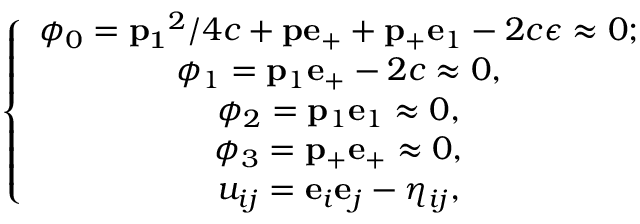<formula> <loc_0><loc_0><loc_500><loc_500>\left \{ \begin{array} { c } { { \phi _ { 0 } = { p _ { 1 } } ^ { 2 } / 4 c + { p } { e } _ { + } + { p _ { + } } { e } _ { 1 } - 2 c \epsilon \approx 0 ; } } \\ { { \phi _ { 1 } = { p } _ { 1 } { e } _ { + } - 2 c \approx 0 , } } \\ { { \phi _ { 2 } = { p } _ { 1 } { e } _ { 1 } \approx 0 , } } \\ { { \phi _ { 3 } = { p } _ { + } { e } _ { + } \approx 0 , } } \\ { { u _ { i j } = { e } _ { i } { e } _ { j } - \eta _ { i j } , } } \end{array}</formula> 